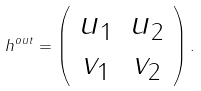Convert formula to latex. <formula><loc_0><loc_0><loc_500><loc_500>h ^ { o u t } = \left ( \begin{array} { c c } u _ { 1 } & u _ { 2 } \\ v _ { 1 } & v _ { 2 } \end{array} \right ) .</formula> 